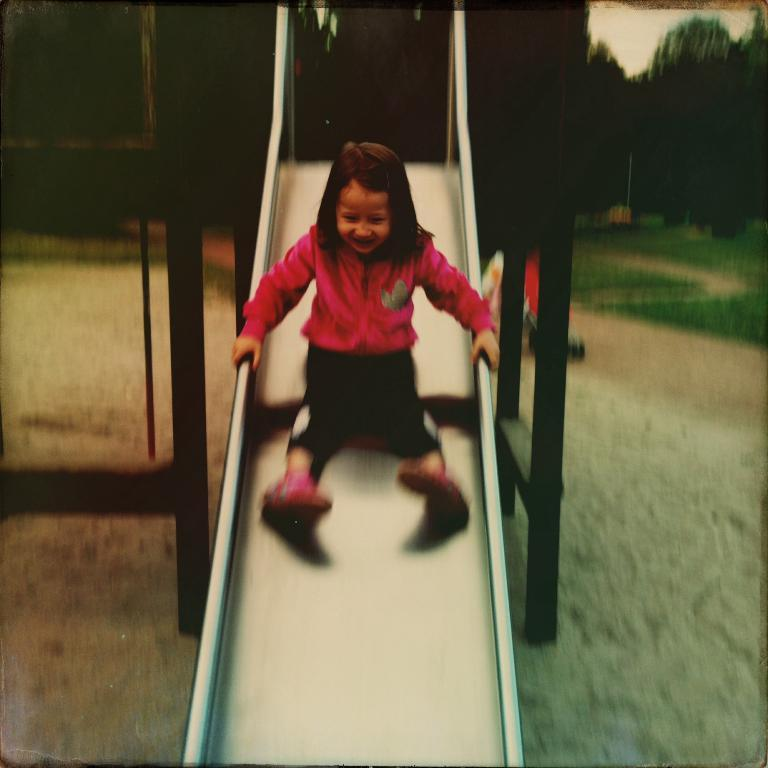What is the main subject of the image? The main subject of the image is a child. What is the child doing in the image? The child is sliding on a garden slide. What can be seen in the background of the image? The background of the image includes trees. What type of hair can be seen on the dime in the image? There is no dime or hair present in the image. How many teeth does the child have in the image? The image does not show the child's teeth, so it cannot be determined from the image. 